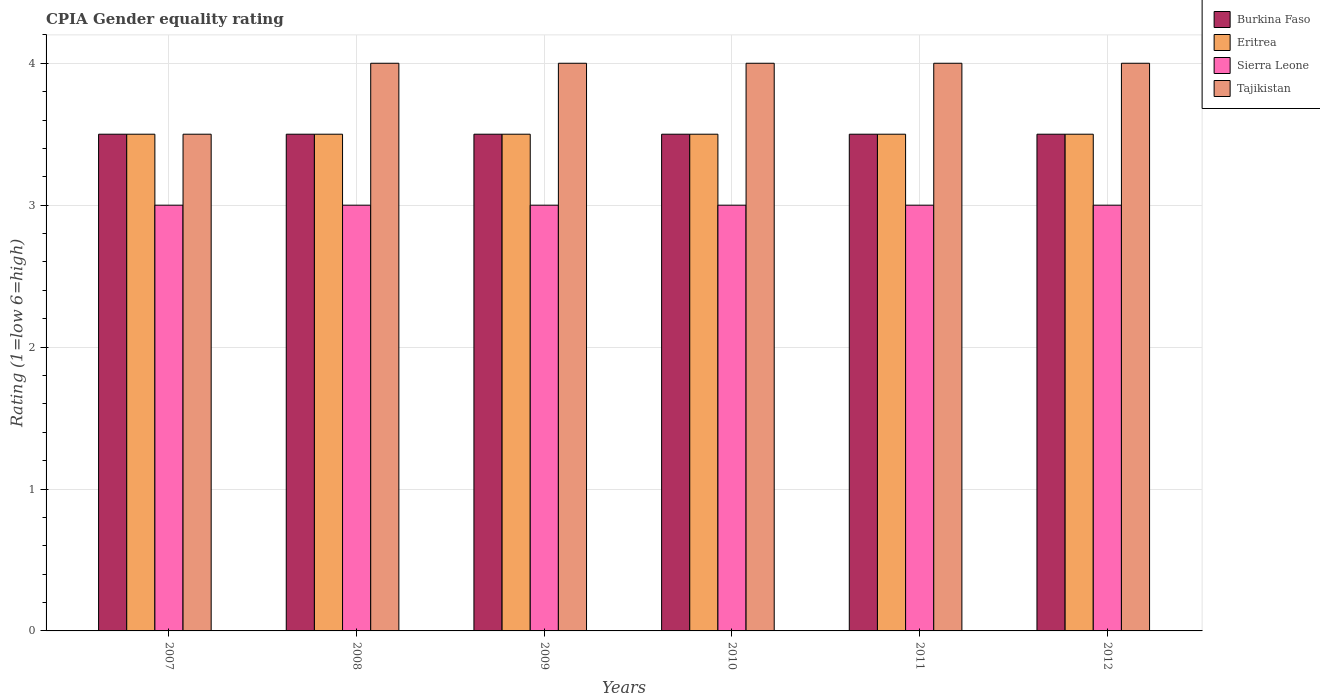How many different coloured bars are there?
Provide a succinct answer. 4. Are the number of bars on each tick of the X-axis equal?
Your answer should be very brief. Yes. How many bars are there on the 3rd tick from the left?
Offer a very short reply. 4. How many bars are there on the 3rd tick from the right?
Offer a terse response. 4. What is the label of the 5th group of bars from the left?
Provide a short and direct response. 2011. In how many cases, is the number of bars for a given year not equal to the number of legend labels?
Keep it short and to the point. 0. Across all years, what is the minimum CPIA rating in Tajikistan?
Your answer should be compact. 3.5. In which year was the CPIA rating in Sierra Leone maximum?
Provide a short and direct response. 2007. In which year was the CPIA rating in Eritrea minimum?
Provide a succinct answer. 2007. What is the total CPIA rating in Sierra Leone in the graph?
Your answer should be very brief. 18. What is the difference between the CPIA rating in Sierra Leone in 2007 and that in 2012?
Keep it short and to the point. 0. What is the average CPIA rating in Eritrea per year?
Make the answer very short. 3.5. In how many years, is the CPIA rating in Sierra Leone greater than 0.8?
Your answer should be very brief. 6. What is the ratio of the CPIA rating in Eritrea in 2009 to that in 2012?
Provide a short and direct response. 1. Is the CPIA rating in Tajikistan in 2008 less than that in 2011?
Provide a short and direct response. No. Is the difference between the CPIA rating in Burkina Faso in 2007 and 2011 greater than the difference between the CPIA rating in Sierra Leone in 2007 and 2011?
Your answer should be very brief. No. Is the sum of the CPIA rating in Sierra Leone in 2008 and 2010 greater than the maximum CPIA rating in Burkina Faso across all years?
Keep it short and to the point. Yes. Is it the case that in every year, the sum of the CPIA rating in Tajikistan and CPIA rating in Eritrea is greater than the sum of CPIA rating in Sierra Leone and CPIA rating in Burkina Faso?
Provide a short and direct response. Yes. What does the 1st bar from the left in 2011 represents?
Offer a terse response. Burkina Faso. What does the 2nd bar from the right in 2012 represents?
Ensure brevity in your answer.  Sierra Leone. Is it the case that in every year, the sum of the CPIA rating in Sierra Leone and CPIA rating in Burkina Faso is greater than the CPIA rating in Tajikistan?
Your response must be concise. Yes. Are all the bars in the graph horizontal?
Give a very brief answer. No. How many years are there in the graph?
Make the answer very short. 6. Are the values on the major ticks of Y-axis written in scientific E-notation?
Keep it short and to the point. No. How are the legend labels stacked?
Give a very brief answer. Vertical. What is the title of the graph?
Your response must be concise. CPIA Gender equality rating. What is the Rating (1=low 6=high) in Tajikistan in 2007?
Ensure brevity in your answer.  3.5. What is the Rating (1=low 6=high) of Burkina Faso in 2008?
Your answer should be compact. 3.5. What is the Rating (1=low 6=high) in Sierra Leone in 2008?
Give a very brief answer. 3. What is the Rating (1=low 6=high) of Tajikistan in 2008?
Make the answer very short. 4. What is the Rating (1=low 6=high) of Tajikistan in 2009?
Keep it short and to the point. 4. What is the Rating (1=low 6=high) in Burkina Faso in 2010?
Your answer should be very brief. 3.5. What is the Rating (1=low 6=high) in Eritrea in 2010?
Give a very brief answer. 3.5. What is the Rating (1=low 6=high) in Tajikistan in 2010?
Your answer should be compact. 4. What is the Rating (1=low 6=high) of Eritrea in 2011?
Offer a very short reply. 3.5. What is the Rating (1=low 6=high) in Sierra Leone in 2011?
Make the answer very short. 3. What is the Rating (1=low 6=high) of Tajikistan in 2011?
Offer a terse response. 4. Across all years, what is the maximum Rating (1=low 6=high) in Eritrea?
Provide a short and direct response. 3.5. Across all years, what is the maximum Rating (1=low 6=high) of Sierra Leone?
Offer a terse response. 3. Across all years, what is the minimum Rating (1=low 6=high) of Burkina Faso?
Offer a very short reply. 3.5. Across all years, what is the minimum Rating (1=low 6=high) in Eritrea?
Provide a short and direct response. 3.5. Across all years, what is the minimum Rating (1=low 6=high) of Tajikistan?
Your answer should be very brief. 3.5. What is the total Rating (1=low 6=high) in Burkina Faso in the graph?
Provide a succinct answer. 21. What is the total Rating (1=low 6=high) of Sierra Leone in the graph?
Provide a succinct answer. 18. What is the difference between the Rating (1=low 6=high) in Burkina Faso in 2007 and that in 2008?
Keep it short and to the point. 0. What is the difference between the Rating (1=low 6=high) in Tajikistan in 2007 and that in 2008?
Offer a terse response. -0.5. What is the difference between the Rating (1=low 6=high) of Burkina Faso in 2007 and that in 2009?
Offer a very short reply. 0. What is the difference between the Rating (1=low 6=high) of Eritrea in 2007 and that in 2009?
Give a very brief answer. 0. What is the difference between the Rating (1=low 6=high) of Sierra Leone in 2007 and that in 2009?
Ensure brevity in your answer.  0. What is the difference between the Rating (1=low 6=high) of Tajikistan in 2007 and that in 2009?
Provide a succinct answer. -0.5. What is the difference between the Rating (1=low 6=high) of Burkina Faso in 2007 and that in 2010?
Offer a very short reply. 0. What is the difference between the Rating (1=low 6=high) of Eritrea in 2007 and that in 2010?
Offer a very short reply. 0. What is the difference between the Rating (1=low 6=high) of Tajikistan in 2007 and that in 2010?
Make the answer very short. -0.5. What is the difference between the Rating (1=low 6=high) of Tajikistan in 2007 and that in 2011?
Offer a terse response. -0.5. What is the difference between the Rating (1=low 6=high) of Sierra Leone in 2007 and that in 2012?
Keep it short and to the point. 0. What is the difference between the Rating (1=low 6=high) in Burkina Faso in 2008 and that in 2009?
Offer a very short reply. 0. What is the difference between the Rating (1=low 6=high) of Eritrea in 2008 and that in 2009?
Your response must be concise. 0. What is the difference between the Rating (1=low 6=high) in Tajikistan in 2008 and that in 2009?
Your answer should be very brief. 0. What is the difference between the Rating (1=low 6=high) of Eritrea in 2008 and that in 2010?
Offer a terse response. 0. What is the difference between the Rating (1=low 6=high) in Tajikistan in 2008 and that in 2010?
Offer a very short reply. 0. What is the difference between the Rating (1=low 6=high) in Burkina Faso in 2008 and that in 2011?
Offer a very short reply. 0. What is the difference between the Rating (1=low 6=high) in Tajikistan in 2008 and that in 2011?
Give a very brief answer. 0. What is the difference between the Rating (1=low 6=high) of Eritrea in 2008 and that in 2012?
Offer a terse response. 0. What is the difference between the Rating (1=low 6=high) in Sierra Leone in 2008 and that in 2012?
Keep it short and to the point. 0. What is the difference between the Rating (1=low 6=high) of Tajikistan in 2008 and that in 2012?
Make the answer very short. 0. What is the difference between the Rating (1=low 6=high) in Eritrea in 2009 and that in 2010?
Offer a very short reply. 0. What is the difference between the Rating (1=low 6=high) in Sierra Leone in 2009 and that in 2010?
Provide a short and direct response. 0. What is the difference between the Rating (1=low 6=high) in Tajikistan in 2009 and that in 2010?
Your answer should be very brief. 0. What is the difference between the Rating (1=low 6=high) of Eritrea in 2009 and that in 2011?
Provide a short and direct response. 0. What is the difference between the Rating (1=low 6=high) in Tajikistan in 2009 and that in 2011?
Give a very brief answer. 0. What is the difference between the Rating (1=low 6=high) in Burkina Faso in 2009 and that in 2012?
Give a very brief answer. 0. What is the difference between the Rating (1=low 6=high) of Eritrea in 2009 and that in 2012?
Your answer should be compact. 0. What is the difference between the Rating (1=low 6=high) in Sierra Leone in 2009 and that in 2012?
Your answer should be compact. 0. What is the difference between the Rating (1=low 6=high) of Burkina Faso in 2010 and that in 2011?
Offer a very short reply. 0. What is the difference between the Rating (1=low 6=high) in Eritrea in 2010 and that in 2011?
Provide a succinct answer. 0. What is the difference between the Rating (1=low 6=high) of Sierra Leone in 2010 and that in 2011?
Your answer should be compact. 0. What is the difference between the Rating (1=low 6=high) of Tajikistan in 2010 and that in 2011?
Offer a terse response. 0. What is the difference between the Rating (1=low 6=high) in Burkina Faso in 2010 and that in 2012?
Give a very brief answer. 0. What is the difference between the Rating (1=low 6=high) in Eritrea in 2010 and that in 2012?
Offer a terse response. 0. What is the difference between the Rating (1=low 6=high) in Sierra Leone in 2010 and that in 2012?
Provide a succinct answer. 0. What is the difference between the Rating (1=low 6=high) of Tajikistan in 2010 and that in 2012?
Give a very brief answer. 0. What is the difference between the Rating (1=low 6=high) in Eritrea in 2011 and that in 2012?
Your response must be concise. 0. What is the difference between the Rating (1=low 6=high) in Burkina Faso in 2007 and the Rating (1=low 6=high) in Eritrea in 2008?
Keep it short and to the point. 0. What is the difference between the Rating (1=low 6=high) in Burkina Faso in 2007 and the Rating (1=low 6=high) in Sierra Leone in 2008?
Offer a terse response. 0.5. What is the difference between the Rating (1=low 6=high) of Burkina Faso in 2007 and the Rating (1=low 6=high) of Tajikistan in 2008?
Your answer should be compact. -0.5. What is the difference between the Rating (1=low 6=high) of Eritrea in 2007 and the Rating (1=low 6=high) of Sierra Leone in 2008?
Offer a very short reply. 0.5. What is the difference between the Rating (1=low 6=high) in Burkina Faso in 2007 and the Rating (1=low 6=high) in Sierra Leone in 2009?
Make the answer very short. 0.5. What is the difference between the Rating (1=low 6=high) of Burkina Faso in 2007 and the Rating (1=low 6=high) of Tajikistan in 2009?
Keep it short and to the point. -0.5. What is the difference between the Rating (1=low 6=high) in Eritrea in 2007 and the Rating (1=low 6=high) in Sierra Leone in 2009?
Give a very brief answer. 0.5. What is the difference between the Rating (1=low 6=high) of Eritrea in 2007 and the Rating (1=low 6=high) of Tajikistan in 2009?
Ensure brevity in your answer.  -0.5. What is the difference between the Rating (1=low 6=high) in Burkina Faso in 2007 and the Rating (1=low 6=high) in Eritrea in 2010?
Make the answer very short. 0. What is the difference between the Rating (1=low 6=high) in Burkina Faso in 2007 and the Rating (1=low 6=high) in Sierra Leone in 2010?
Provide a succinct answer. 0.5. What is the difference between the Rating (1=low 6=high) in Burkina Faso in 2007 and the Rating (1=low 6=high) in Tajikistan in 2010?
Make the answer very short. -0.5. What is the difference between the Rating (1=low 6=high) in Eritrea in 2007 and the Rating (1=low 6=high) in Sierra Leone in 2010?
Your answer should be compact. 0.5. What is the difference between the Rating (1=low 6=high) in Sierra Leone in 2007 and the Rating (1=low 6=high) in Tajikistan in 2010?
Keep it short and to the point. -1. What is the difference between the Rating (1=low 6=high) of Burkina Faso in 2007 and the Rating (1=low 6=high) of Eritrea in 2011?
Offer a terse response. 0. What is the difference between the Rating (1=low 6=high) in Eritrea in 2007 and the Rating (1=low 6=high) in Sierra Leone in 2011?
Your response must be concise. 0.5. What is the difference between the Rating (1=low 6=high) in Burkina Faso in 2007 and the Rating (1=low 6=high) in Eritrea in 2012?
Provide a succinct answer. 0. What is the difference between the Rating (1=low 6=high) in Burkina Faso in 2007 and the Rating (1=low 6=high) in Sierra Leone in 2012?
Make the answer very short. 0.5. What is the difference between the Rating (1=low 6=high) of Burkina Faso in 2007 and the Rating (1=low 6=high) of Tajikistan in 2012?
Your answer should be very brief. -0.5. What is the difference between the Rating (1=low 6=high) of Eritrea in 2007 and the Rating (1=low 6=high) of Sierra Leone in 2012?
Offer a terse response. 0.5. What is the difference between the Rating (1=low 6=high) in Burkina Faso in 2008 and the Rating (1=low 6=high) in Eritrea in 2009?
Keep it short and to the point. 0. What is the difference between the Rating (1=low 6=high) in Eritrea in 2008 and the Rating (1=low 6=high) in Sierra Leone in 2009?
Offer a terse response. 0.5. What is the difference between the Rating (1=low 6=high) in Burkina Faso in 2008 and the Rating (1=low 6=high) in Eritrea in 2010?
Your answer should be very brief. 0. What is the difference between the Rating (1=low 6=high) in Burkina Faso in 2008 and the Rating (1=low 6=high) in Sierra Leone in 2010?
Keep it short and to the point. 0.5. What is the difference between the Rating (1=low 6=high) of Burkina Faso in 2008 and the Rating (1=low 6=high) of Tajikistan in 2010?
Make the answer very short. -0.5. What is the difference between the Rating (1=low 6=high) in Eritrea in 2008 and the Rating (1=low 6=high) in Sierra Leone in 2010?
Give a very brief answer. 0.5. What is the difference between the Rating (1=low 6=high) of Eritrea in 2008 and the Rating (1=low 6=high) of Tajikistan in 2010?
Offer a terse response. -0.5. What is the difference between the Rating (1=low 6=high) in Burkina Faso in 2008 and the Rating (1=low 6=high) in Eritrea in 2011?
Offer a very short reply. 0. What is the difference between the Rating (1=low 6=high) of Burkina Faso in 2008 and the Rating (1=low 6=high) of Sierra Leone in 2011?
Your response must be concise. 0.5. What is the difference between the Rating (1=low 6=high) of Burkina Faso in 2008 and the Rating (1=low 6=high) of Tajikistan in 2011?
Provide a short and direct response. -0.5. What is the difference between the Rating (1=low 6=high) in Eritrea in 2008 and the Rating (1=low 6=high) in Tajikistan in 2011?
Make the answer very short. -0.5. What is the difference between the Rating (1=low 6=high) of Sierra Leone in 2008 and the Rating (1=low 6=high) of Tajikistan in 2011?
Keep it short and to the point. -1. What is the difference between the Rating (1=low 6=high) of Burkina Faso in 2008 and the Rating (1=low 6=high) of Eritrea in 2012?
Give a very brief answer. 0. What is the difference between the Rating (1=low 6=high) in Burkina Faso in 2008 and the Rating (1=low 6=high) in Sierra Leone in 2012?
Give a very brief answer. 0.5. What is the difference between the Rating (1=low 6=high) of Burkina Faso in 2009 and the Rating (1=low 6=high) of Sierra Leone in 2010?
Your answer should be very brief. 0.5. What is the difference between the Rating (1=low 6=high) of Burkina Faso in 2009 and the Rating (1=low 6=high) of Tajikistan in 2010?
Ensure brevity in your answer.  -0.5. What is the difference between the Rating (1=low 6=high) of Eritrea in 2009 and the Rating (1=low 6=high) of Sierra Leone in 2010?
Make the answer very short. 0.5. What is the difference between the Rating (1=low 6=high) of Sierra Leone in 2009 and the Rating (1=low 6=high) of Tajikistan in 2010?
Your answer should be compact. -1. What is the difference between the Rating (1=low 6=high) in Burkina Faso in 2009 and the Rating (1=low 6=high) in Sierra Leone in 2011?
Your answer should be very brief. 0.5. What is the difference between the Rating (1=low 6=high) of Burkina Faso in 2009 and the Rating (1=low 6=high) of Tajikistan in 2011?
Give a very brief answer. -0.5. What is the difference between the Rating (1=low 6=high) of Sierra Leone in 2009 and the Rating (1=low 6=high) of Tajikistan in 2011?
Keep it short and to the point. -1. What is the difference between the Rating (1=low 6=high) in Burkina Faso in 2009 and the Rating (1=low 6=high) in Sierra Leone in 2012?
Keep it short and to the point. 0.5. What is the difference between the Rating (1=low 6=high) of Burkina Faso in 2009 and the Rating (1=low 6=high) of Tajikistan in 2012?
Keep it short and to the point. -0.5. What is the difference between the Rating (1=low 6=high) in Sierra Leone in 2009 and the Rating (1=low 6=high) in Tajikistan in 2012?
Your response must be concise. -1. What is the difference between the Rating (1=low 6=high) of Burkina Faso in 2010 and the Rating (1=low 6=high) of Eritrea in 2011?
Offer a terse response. 0. What is the difference between the Rating (1=low 6=high) in Sierra Leone in 2010 and the Rating (1=low 6=high) in Tajikistan in 2011?
Offer a terse response. -1. What is the difference between the Rating (1=low 6=high) in Burkina Faso in 2010 and the Rating (1=low 6=high) in Sierra Leone in 2012?
Your answer should be very brief. 0.5. What is the difference between the Rating (1=low 6=high) of Burkina Faso in 2011 and the Rating (1=low 6=high) of Eritrea in 2012?
Provide a short and direct response. 0. What is the difference between the Rating (1=low 6=high) in Burkina Faso in 2011 and the Rating (1=low 6=high) in Tajikistan in 2012?
Your answer should be compact. -0.5. What is the difference between the Rating (1=low 6=high) in Eritrea in 2011 and the Rating (1=low 6=high) in Sierra Leone in 2012?
Provide a succinct answer. 0.5. What is the difference between the Rating (1=low 6=high) of Eritrea in 2011 and the Rating (1=low 6=high) of Tajikistan in 2012?
Ensure brevity in your answer.  -0.5. What is the difference between the Rating (1=low 6=high) in Sierra Leone in 2011 and the Rating (1=low 6=high) in Tajikistan in 2012?
Offer a very short reply. -1. What is the average Rating (1=low 6=high) of Burkina Faso per year?
Offer a terse response. 3.5. What is the average Rating (1=low 6=high) in Tajikistan per year?
Offer a very short reply. 3.92. In the year 2007, what is the difference between the Rating (1=low 6=high) in Burkina Faso and Rating (1=low 6=high) in Eritrea?
Make the answer very short. 0. In the year 2007, what is the difference between the Rating (1=low 6=high) of Burkina Faso and Rating (1=low 6=high) of Sierra Leone?
Your response must be concise. 0.5. In the year 2007, what is the difference between the Rating (1=low 6=high) of Sierra Leone and Rating (1=low 6=high) of Tajikistan?
Offer a terse response. -0.5. In the year 2008, what is the difference between the Rating (1=low 6=high) of Burkina Faso and Rating (1=low 6=high) of Eritrea?
Your response must be concise. 0. In the year 2008, what is the difference between the Rating (1=low 6=high) in Burkina Faso and Rating (1=low 6=high) in Sierra Leone?
Give a very brief answer. 0.5. In the year 2008, what is the difference between the Rating (1=low 6=high) of Burkina Faso and Rating (1=low 6=high) of Tajikistan?
Offer a very short reply. -0.5. In the year 2008, what is the difference between the Rating (1=low 6=high) in Eritrea and Rating (1=low 6=high) in Sierra Leone?
Offer a very short reply. 0.5. In the year 2008, what is the difference between the Rating (1=low 6=high) of Eritrea and Rating (1=low 6=high) of Tajikistan?
Offer a terse response. -0.5. In the year 2008, what is the difference between the Rating (1=low 6=high) of Sierra Leone and Rating (1=low 6=high) of Tajikistan?
Make the answer very short. -1. In the year 2009, what is the difference between the Rating (1=low 6=high) of Eritrea and Rating (1=low 6=high) of Tajikistan?
Your response must be concise. -0.5. In the year 2009, what is the difference between the Rating (1=low 6=high) in Sierra Leone and Rating (1=low 6=high) in Tajikistan?
Your answer should be compact. -1. In the year 2010, what is the difference between the Rating (1=low 6=high) in Burkina Faso and Rating (1=low 6=high) in Sierra Leone?
Your response must be concise. 0.5. In the year 2011, what is the difference between the Rating (1=low 6=high) of Burkina Faso and Rating (1=low 6=high) of Sierra Leone?
Ensure brevity in your answer.  0.5. In the year 2011, what is the difference between the Rating (1=low 6=high) of Eritrea and Rating (1=low 6=high) of Sierra Leone?
Your answer should be compact. 0.5. In the year 2011, what is the difference between the Rating (1=low 6=high) in Eritrea and Rating (1=low 6=high) in Tajikistan?
Provide a short and direct response. -0.5. In the year 2012, what is the difference between the Rating (1=low 6=high) of Eritrea and Rating (1=low 6=high) of Tajikistan?
Make the answer very short. -0.5. In the year 2012, what is the difference between the Rating (1=low 6=high) of Sierra Leone and Rating (1=low 6=high) of Tajikistan?
Give a very brief answer. -1. What is the ratio of the Rating (1=low 6=high) in Burkina Faso in 2007 to that in 2010?
Provide a succinct answer. 1. What is the ratio of the Rating (1=low 6=high) of Sierra Leone in 2007 to that in 2010?
Your response must be concise. 1. What is the ratio of the Rating (1=low 6=high) of Sierra Leone in 2007 to that in 2011?
Your answer should be compact. 1. What is the ratio of the Rating (1=low 6=high) of Eritrea in 2007 to that in 2012?
Your answer should be compact. 1. What is the ratio of the Rating (1=low 6=high) in Sierra Leone in 2007 to that in 2012?
Offer a very short reply. 1. What is the ratio of the Rating (1=low 6=high) of Eritrea in 2008 to that in 2009?
Provide a succinct answer. 1. What is the ratio of the Rating (1=low 6=high) of Sierra Leone in 2008 to that in 2009?
Your answer should be compact. 1. What is the ratio of the Rating (1=low 6=high) in Tajikistan in 2008 to that in 2009?
Make the answer very short. 1. What is the ratio of the Rating (1=low 6=high) of Burkina Faso in 2008 to that in 2011?
Make the answer very short. 1. What is the ratio of the Rating (1=low 6=high) of Eritrea in 2008 to that in 2011?
Give a very brief answer. 1. What is the ratio of the Rating (1=low 6=high) in Burkina Faso in 2008 to that in 2012?
Your answer should be very brief. 1. What is the ratio of the Rating (1=low 6=high) in Eritrea in 2008 to that in 2012?
Offer a terse response. 1. What is the ratio of the Rating (1=low 6=high) of Sierra Leone in 2008 to that in 2012?
Your response must be concise. 1. What is the ratio of the Rating (1=low 6=high) of Burkina Faso in 2009 to that in 2010?
Give a very brief answer. 1. What is the ratio of the Rating (1=low 6=high) in Tajikistan in 2009 to that in 2010?
Offer a very short reply. 1. What is the ratio of the Rating (1=low 6=high) of Eritrea in 2009 to that in 2011?
Your answer should be compact. 1. What is the ratio of the Rating (1=low 6=high) of Sierra Leone in 2009 to that in 2011?
Your answer should be compact. 1. What is the ratio of the Rating (1=low 6=high) in Sierra Leone in 2009 to that in 2012?
Keep it short and to the point. 1. What is the ratio of the Rating (1=low 6=high) of Burkina Faso in 2010 to that in 2011?
Offer a very short reply. 1. What is the ratio of the Rating (1=low 6=high) of Eritrea in 2010 to that in 2011?
Offer a very short reply. 1. What is the ratio of the Rating (1=low 6=high) in Sierra Leone in 2010 to that in 2011?
Offer a terse response. 1. What is the ratio of the Rating (1=low 6=high) in Tajikistan in 2010 to that in 2011?
Your answer should be compact. 1. What is the ratio of the Rating (1=low 6=high) in Eritrea in 2010 to that in 2012?
Keep it short and to the point. 1. What is the ratio of the Rating (1=low 6=high) of Burkina Faso in 2011 to that in 2012?
Give a very brief answer. 1. What is the ratio of the Rating (1=low 6=high) of Eritrea in 2011 to that in 2012?
Ensure brevity in your answer.  1. What is the ratio of the Rating (1=low 6=high) of Sierra Leone in 2011 to that in 2012?
Your answer should be compact. 1. What is the difference between the highest and the second highest Rating (1=low 6=high) in Eritrea?
Keep it short and to the point. 0. What is the difference between the highest and the lowest Rating (1=low 6=high) of Burkina Faso?
Provide a succinct answer. 0. What is the difference between the highest and the lowest Rating (1=low 6=high) of Eritrea?
Your answer should be very brief. 0. 